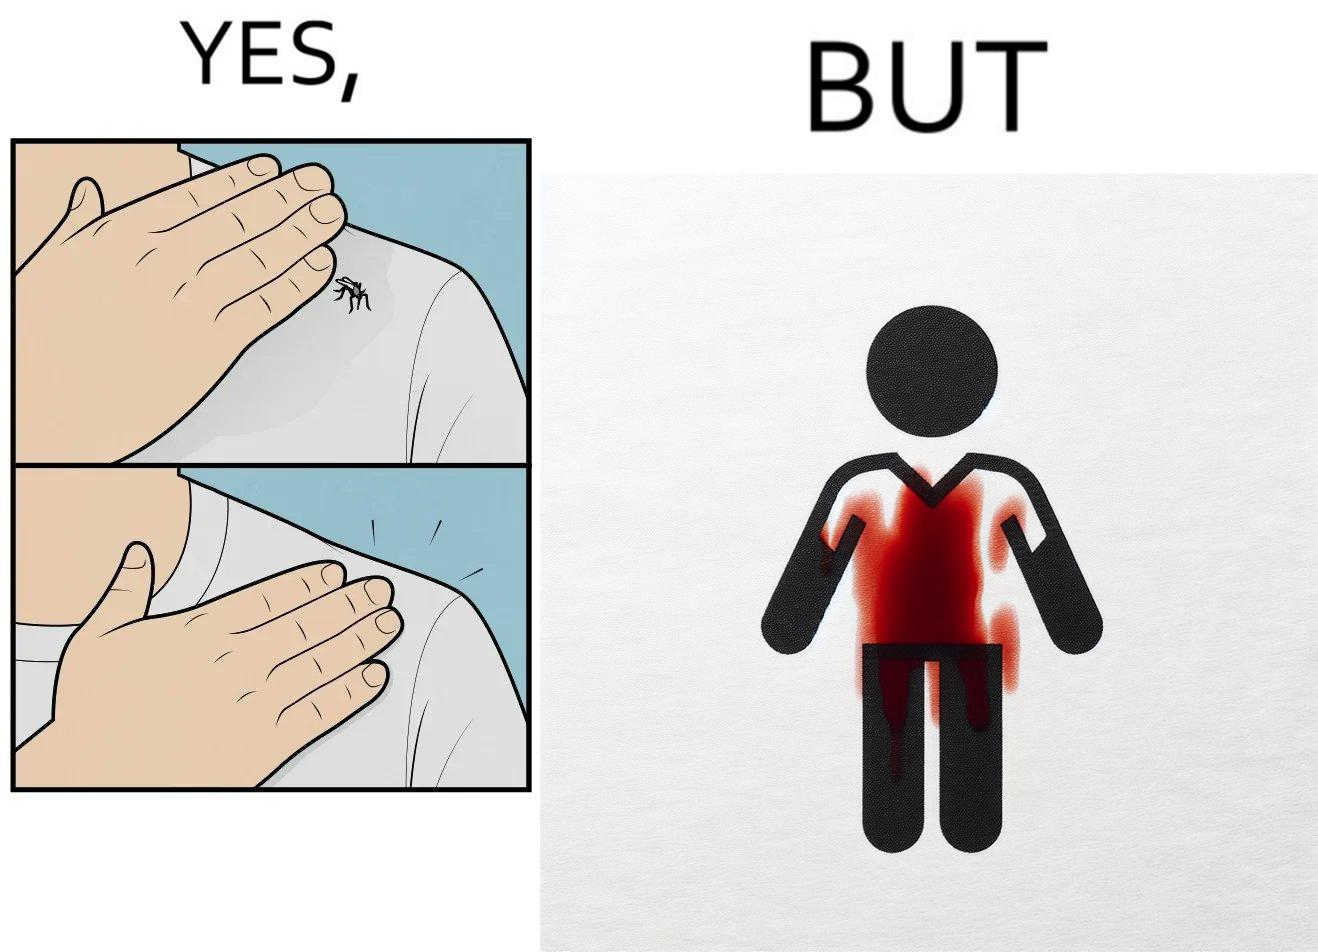Describe what you see in this image. The images are funny since a man trying to reduce his irritation by killing a mosquito bothering  him only causes himself more irritation by soiling his t-shirt with the mosquito blood 